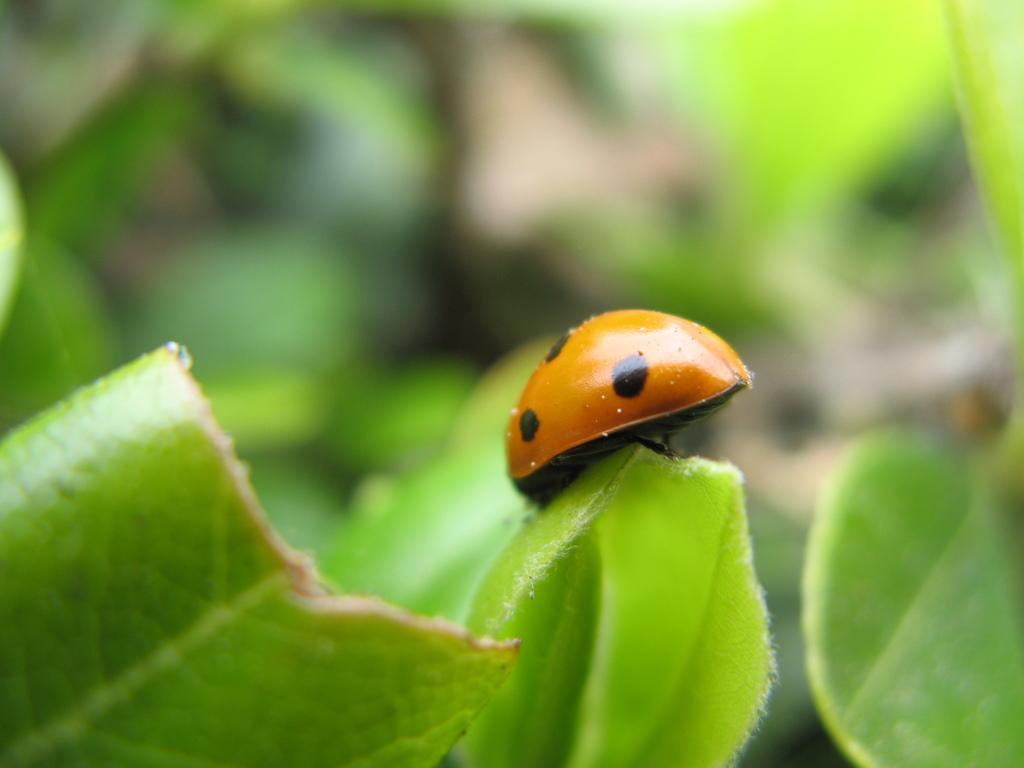What type of creature is in the image? There is an insect in the image. What colors can be seen on the insect? The insect has black and orange colors. Where is the insect located in the image? The insect is on a green leaf. How would you describe the background of the image? The background of the image is blurred. What type of quill is the insect using to write on the pot in the image? There is no quill or pot present in the image; it only features an insect on a green leaf with a blurred background. 